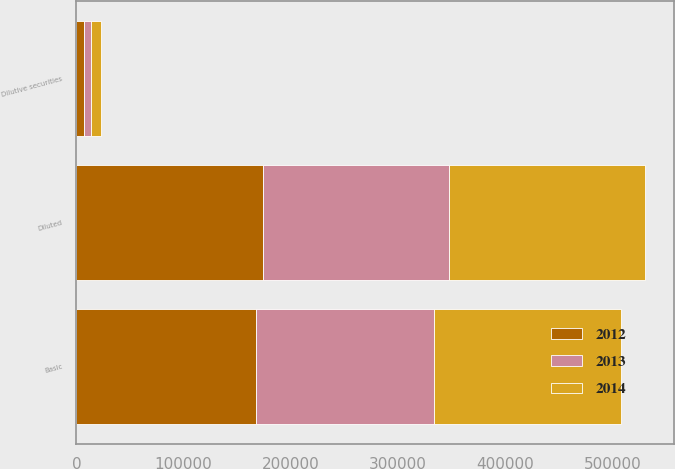Convert chart to OTSL. <chart><loc_0><loc_0><loc_500><loc_500><stacked_bar_chart><ecel><fcel>Basic<fcel>Dilutive securities<fcel>Diluted<nl><fcel>2012<fcel>167257<fcel>7028<fcel>174285<nl><fcel>2013<fcel>166679<fcel>6708<fcel>173387<nl><fcel>2014<fcel>173712<fcel>9371<fcel>183083<nl></chart> 